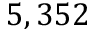<formula> <loc_0><loc_0><loc_500><loc_500>5 , 3 5 2</formula> 